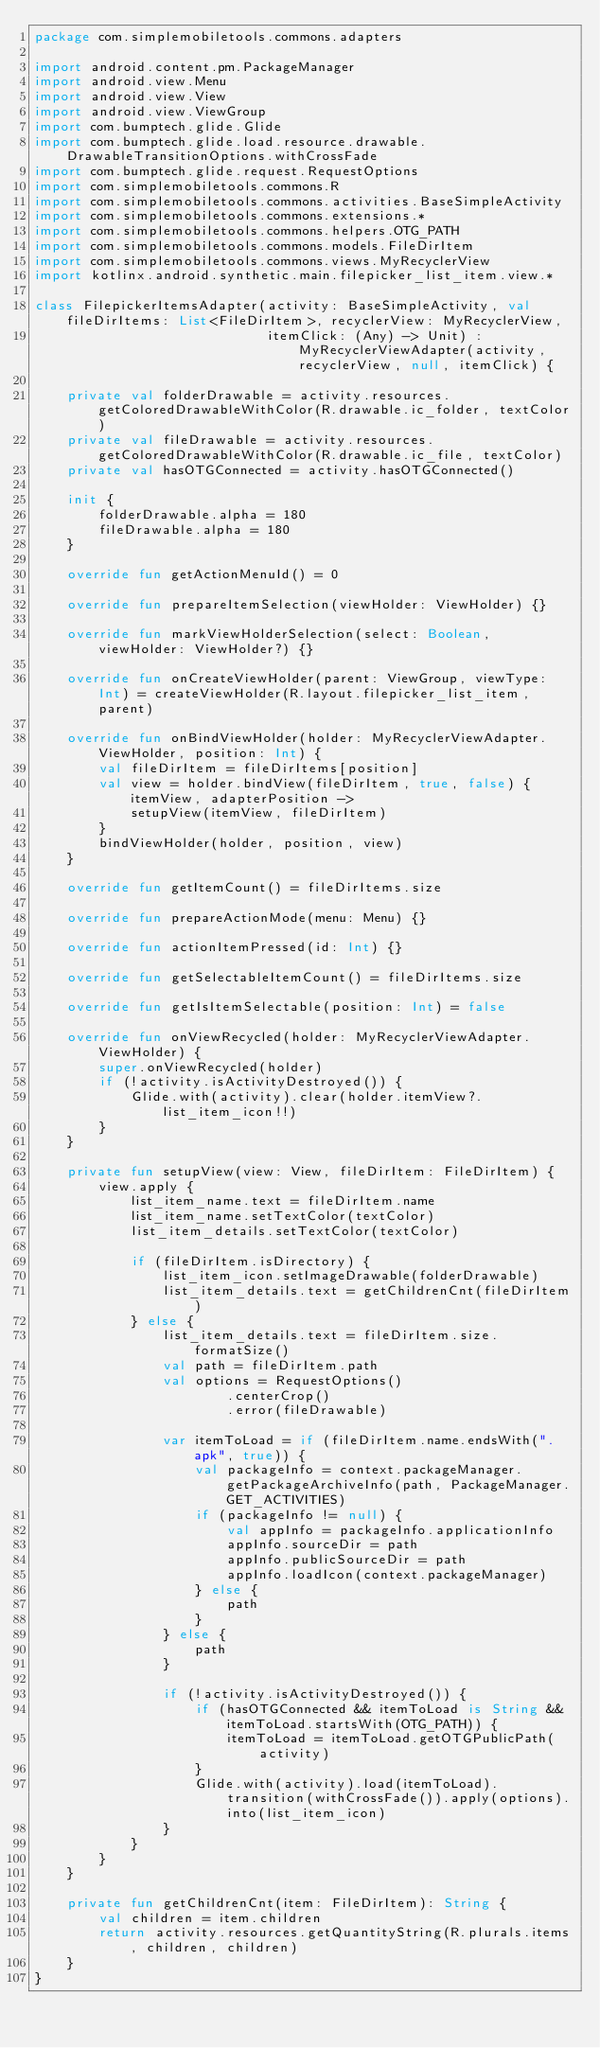<code> <loc_0><loc_0><loc_500><loc_500><_Kotlin_>package com.simplemobiletools.commons.adapters

import android.content.pm.PackageManager
import android.view.Menu
import android.view.View
import android.view.ViewGroup
import com.bumptech.glide.Glide
import com.bumptech.glide.load.resource.drawable.DrawableTransitionOptions.withCrossFade
import com.bumptech.glide.request.RequestOptions
import com.simplemobiletools.commons.R
import com.simplemobiletools.commons.activities.BaseSimpleActivity
import com.simplemobiletools.commons.extensions.*
import com.simplemobiletools.commons.helpers.OTG_PATH
import com.simplemobiletools.commons.models.FileDirItem
import com.simplemobiletools.commons.views.MyRecyclerView
import kotlinx.android.synthetic.main.filepicker_list_item.view.*

class FilepickerItemsAdapter(activity: BaseSimpleActivity, val fileDirItems: List<FileDirItem>, recyclerView: MyRecyclerView,
                             itemClick: (Any) -> Unit) : MyRecyclerViewAdapter(activity, recyclerView, null, itemClick) {

    private val folderDrawable = activity.resources.getColoredDrawableWithColor(R.drawable.ic_folder, textColor)
    private val fileDrawable = activity.resources.getColoredDrawableWithColor(R.drawable.ic_file, textColor)
    private val hasOTGConnected = activity.hasOTGConnected()

    init {
        folderDrawable.alpha = 180
        fileDrawable.alpha = 180
    }

    override fun getActionMenuId() = 0

    override fun prepareItemSelection(viewHolder: ViewHolder) {}

    override fun markViewHolderSelection(select: Boolean, viewHolder: ViewHolder?) {}

    override fun onCreateViewHolder(parent: ViewGroup, viewType: Int) = createViewHolder(R.layout.filepicker_list_item, parent)

    override fun onBindViewHolder(holder: MyRecyclerViewAdapter.ViewHolder, position: Int) {
        val fileDirItem = fileDirItems[position]
        val view = holder.bindView(fileDirItem, true, false) { itemView, adapterPosition ->
            setupView(itemView, fileDirItem)
        }
        bindViewHolder(holder, position, view)
    }

    override fun getItemCount() = fileDirItems.size

    override fun prepareActionMode(menu: Menu) {}

    override fun actionItemPressed(id: Int) {}

    override fun getSelectableItemCount() = fileDirItems.size

    override fun getIsItemSelectable(position: Int) = false

    override fun onViewRecycled(holder: MyRecyclerViewAdapter.ViewHolder) {
        super.onViewRecycled(holder)
        if (!activity.isActivityDestroyed()) {
            Glide.with(activity).clear(holder.itemView?.list_item_icon!!)
        }
    }

    private fun setupView(view: View, fileDirItem: FileDirItem) {
        view.apply {
            list_item_name.text = fileDirItem.name
            list_item_name.setTextColor(textColor)
            list_item_details.setTextColor(textColor)

            if (fileDirItem.isDirectory) {
                list_item_icon.setImageDrawable(folderDrawable)
                list_item_details.text = getChildrenCnt(fileDirItem)
            } else {
                list_item_details.text = fileDirItem.size.formatSize()
                val path = fileDirItem.path
                val options = RequestOptions()
                        .centerCrop()
                        .error(fileDrawable)

                var itemToLoad = if (fileDirItem.name.endsWith(".apk", true)) {
                    val packageInfo = context.packageManager.getPackageArchiveInfo(path, PackageManager.GET_ACTIVITIES)
                    if (packageInfo != null) {
                        val appInfo = packageInfo.applicationInfo
                        appInfo.sourceDir = path
                        appInfo.publicSourceDir = path
                        appInfo.loadIcon(context.packageManager)
                    } else {
                        path
                    }
                } else {
                    path
                }

                if (!activity.isActivityDestroyed()) {
                    if (hasOTGConnected && itemToLoad is String && itemToLoad.startsWith(OTG_PATH)) {
                        itemToLoad = itemToLoad.getOTGPublicPath(activity)
                    }
                    Glide.with(activity).load(itemToLoad).transition(withCrossFade()).apply(options).into(list_item_icon)
                }
            }
        }
    }

    private fun getChildrenCnt(item: FileDirItem): String {
        val children = item.children
        return activity.resources.getQuantityString(R.plurals.items, children, children)
    }
}
</code> 